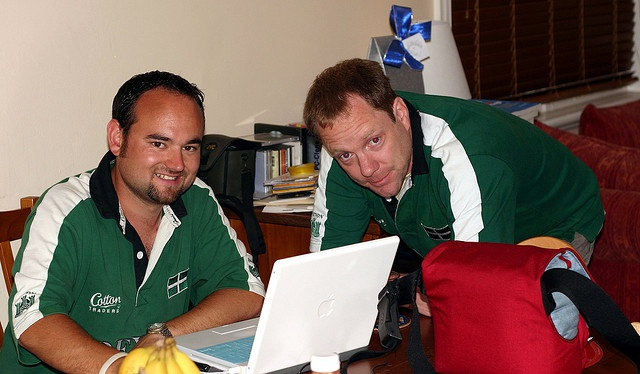Describe the objects in this image and their specific colors. I can see people in lightgray, darkgreen, black, and brown tones, people in lightgray, black, brown, and darkgreen tones, backpack in lightgray, brown, black, and maroon tones, handbag in lightgray, brown, black, and maroon tones, and laptop in lightgray, white, darkgray, teal, and gray tones in this image. 